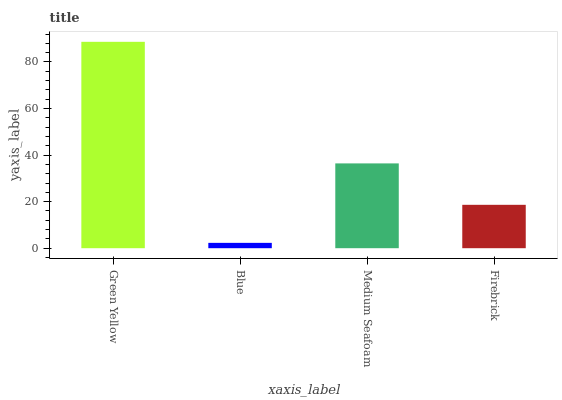Is Blue the minimum?
Answer yes or no. Yes. Is Green Yellow the maximum?
Answer yes or no. Yes. Is Medium Seafoam the minimum?
Answer yes or no. No. Is Medium Seafoam the maximum?
Answer yes or no. No. Is Medium Seafoam greater than Blue?
Answer yes or no. Yes. Is Blue less than Medium Seafoam?
Answer yes or no. Yes. Is Blue greater than Medium Seafoam?
Answer yes or no. No. Is Medium Seafoam less than Blue?
Answer yes or no. No. Is Medium Seafoam the high median?
Answer yes or no. Yes. Is Firebrick the low median?
Answer yes or no. Yes. Is Green Yellow the high median?
Answer yes or no. No. Is Blue the low median?
Answer yes or no. No. 